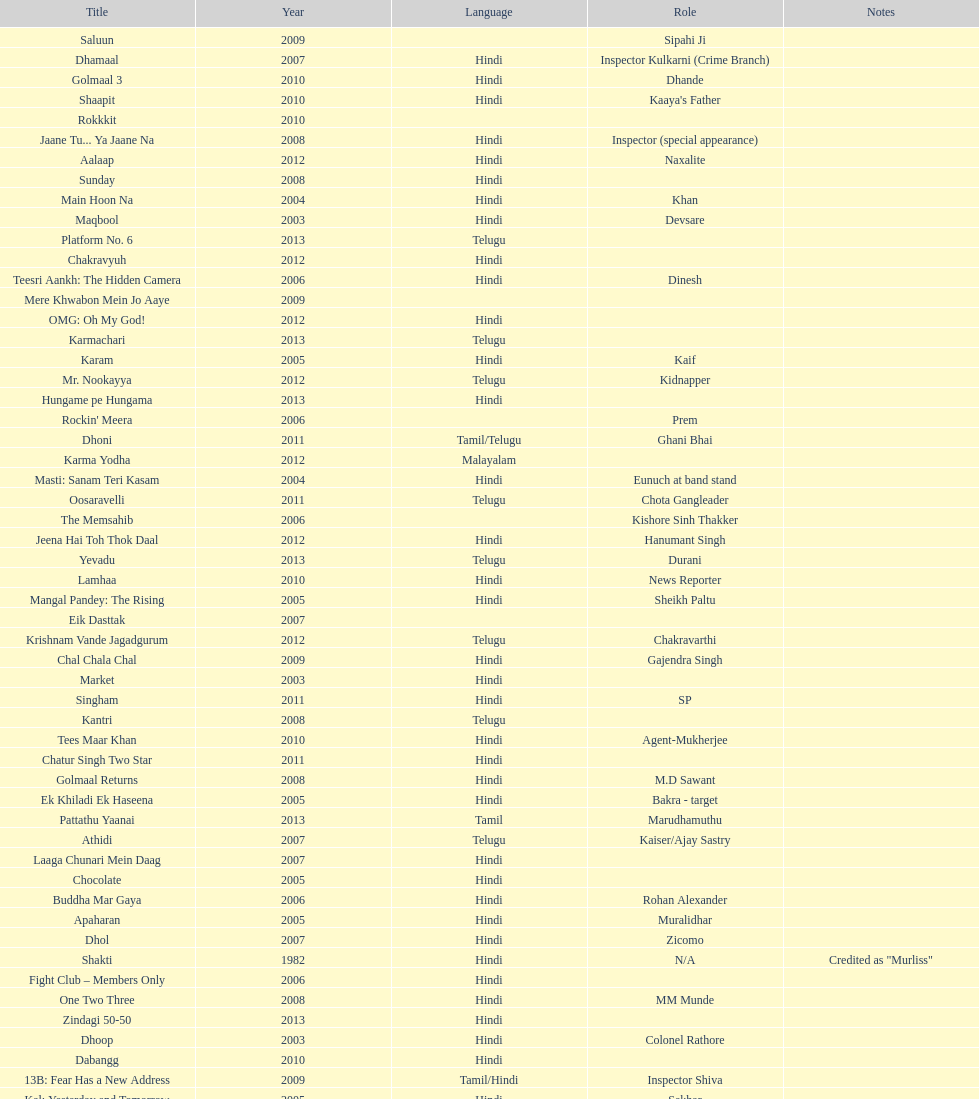What are the number of titles listed in 2005? 6. Give me the full table as a dictionary. {'header': ['Title', 'Year', 'Language', 'Role', 'Notes'], 'rows': [['Saluun', '2009', '', 'Sipahi Ji', ''], ['Dhamaal', '2007', 'Hindi', 'Inspector Kulkarni (Crime Branch)', ''], ['Golmaal 3', '2010', 'Hindi', 'Dhande', ''], ['Shaapit', '2010', 'Hindi', "Kaaya's Father", ''], ['Rokkkit', '2010', '', '', ''], ['Jaane Tu... Ya Jaane Na', '2008', 'Hindi', 'Inspector (special appearance)', ''], ['Aalaap', '2012', 'Hindi', 'Naxalite', ''], ['Sunday', '2008', 'Hindi', '', ''], ['Main Hoon Na', '2004', 'Hindi', 'Khan', ''], ['Maqbool', '2003', 'Hindi', 'Devsare', ''], ['Platform No. 6', '2013', 'Telugu', '', ''], ['Chakravyuh', '2012', 'Hindi', '', ''], ['Teesri Aankh: The Hidden Camera', '2006', 'Hindi', 'Dinesh', ''], ['Mere Khwabon Mein Jo Aaye', '2009', '', '', ''], ['OMG: Oh My God!', '2012', 'Hindi', '', ''], ['Karmachari', '2013', 'Telugu', '', ''], ['Karam', '2005', 'Hindi', 'Kaif', ''], ['Mr. Nookayya', '2012', 'Telugu', 'Kidnapper', ''], ['Hungame pe Hungama', '2013', 'Hindi', '', ''], ["Rockin' Meera", '2006', '', 'Prem', ''], ['Dhoni', '2011', 'Tamil/Telugu', 'Ghani Bhai', ''], ['Karma Yodha', '2012', 'Malayalam', '', ''], ['Masti: Sanam Teri Kasam', '2004', 'Hindi', 'Eunuch at band stand', ''], ['Oosaravelli', '2011', 'Telugu', 'Chota Gangleader', ''], ['The Memsahib', '2006', '', 'Kishore Sinh Thakker', ''], ['Jeena Hai Toh Thok Daal', '2012', 'Hindi', 'Hanumant Singh', ''], ['Yevadu', '2013', 'Telugu', 'Durani', ''], ['Lamhaa', '2010', 'Hindi', 'News Reporter', ''], ['Mangal Pandey: The Rising', '2005', 'Hindi', 'Sheikh Paltu', ''], ['Eik Dasttak', '2007', '', '', ''], ['Krishnam Vande Jagadgurum', '2012', 'Telugu', 'Chakravarthi', ''], ['Chal Chala Chal', '2009', 'Hindi', 'Gajendra Singh', ''], ['Market', '2003', 'Hindi', '', ''], ['Singham', '2011', 'Hindi', 'SP', ''], ['Kantri', '2008', 'Telugu', '', ''], ['Tees Maar Khan', '2010', 'Hindi', 'Agent-Mukherjee', ''], ['Chatur Singh Two Star', '2011', 'Hindi', '', ''], ['Golmaal Returns', '2008', 'Hindi', 'M.D Sawant', ''], ['Ek Khiladi Ek Haseena', '2005', 'Hindi', 'Bakra - target', ''], ['Pattathu Yaanai', '2013', 'Tamil', 'Marudhamuthu', ''], ['Athidi', '2007', 'Telugu', 'Kaiser/Ajay Sastry', ''], ['Laaga Chunari Mein Daag', '2007', 'Hindi', '', ''], ['Chocolate', '2005', 'Hindi', '', ''], ['Buddha Mar Gaya', '2006', 'Hindi', 'Rohan Alexander', ''], ['Apaharan', '2005', 'Hindi', 'Muralidhar', ''], ['Dhol', '2007', 'Hindi', 'Zicomo', ''], ['Shakti', '1982', 'Hindi', 'N/A', 'Credited as "Murliss"'], ['Fight Club – Members Only', '2006', 'Hindi', '', ''], ['One Two Three', '2008', 'Hindi', 'MM Munde', ''], ['Zindagi 50-50', '2013', 'Hindi', '', ''], ['Dhoop', '2003', 'Hindi', 'Colonel Rathore', ''], ['Dabangg', '2010', 'Hindi', '', ''], ['13B: Fear Has a New Address', '2009', 'Tamil/Hindi', 'Inspector Shiva', ''], ['Kal: Yesterday and Tomorrow', '2005', 'Hindi', 'Sekhar', ''], ['Black Friday', '2004', 'Hindi', '', ''], ['Dil Vil Pyar Vyar', '2002', 'Hindi', 'N/A', ''], ['Choron Ki Baraat', '2012', 'Hindi', 'Tejeshwar Singh', '']]} 